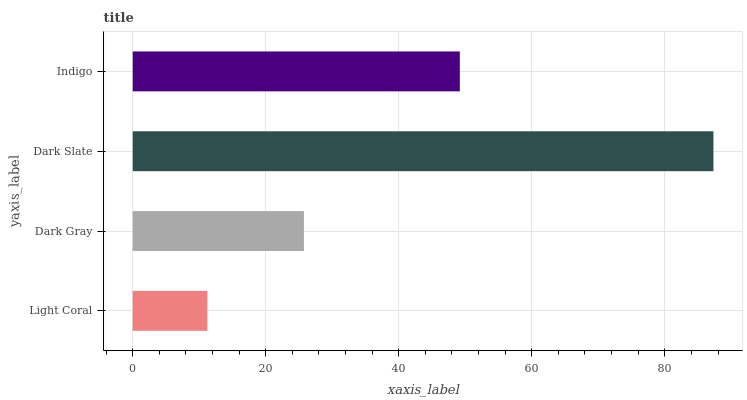Is Light Coral the minimum?
Answer yes or no. Yes. Is Dark Slate the maximum?
Answer yes or no. Yes. Is Dark Gray the minimum?
Answer yes or no. No. Is Dark Gray the maximum?
Answer yes or no. No. Is Dark Gray greater than Light Coral?
Answer yes or no. Yes. Is Light Coral less than Dark Gray?
Answer yes or no. Yes. Is Light Coral greater than Dark Gray?
Answer yes or no. No. Is Dark Gray less than Light Coral?
Answer yes or no. No. Is Indigo the high median?
Answer yes or no. Yes. Is Dark Gray the low median?
Answer yes or no. Yes. Is Dark Slate the high median?
Answer yes or no. No. Is Indigo the low median?
Answer yes or no. No. 